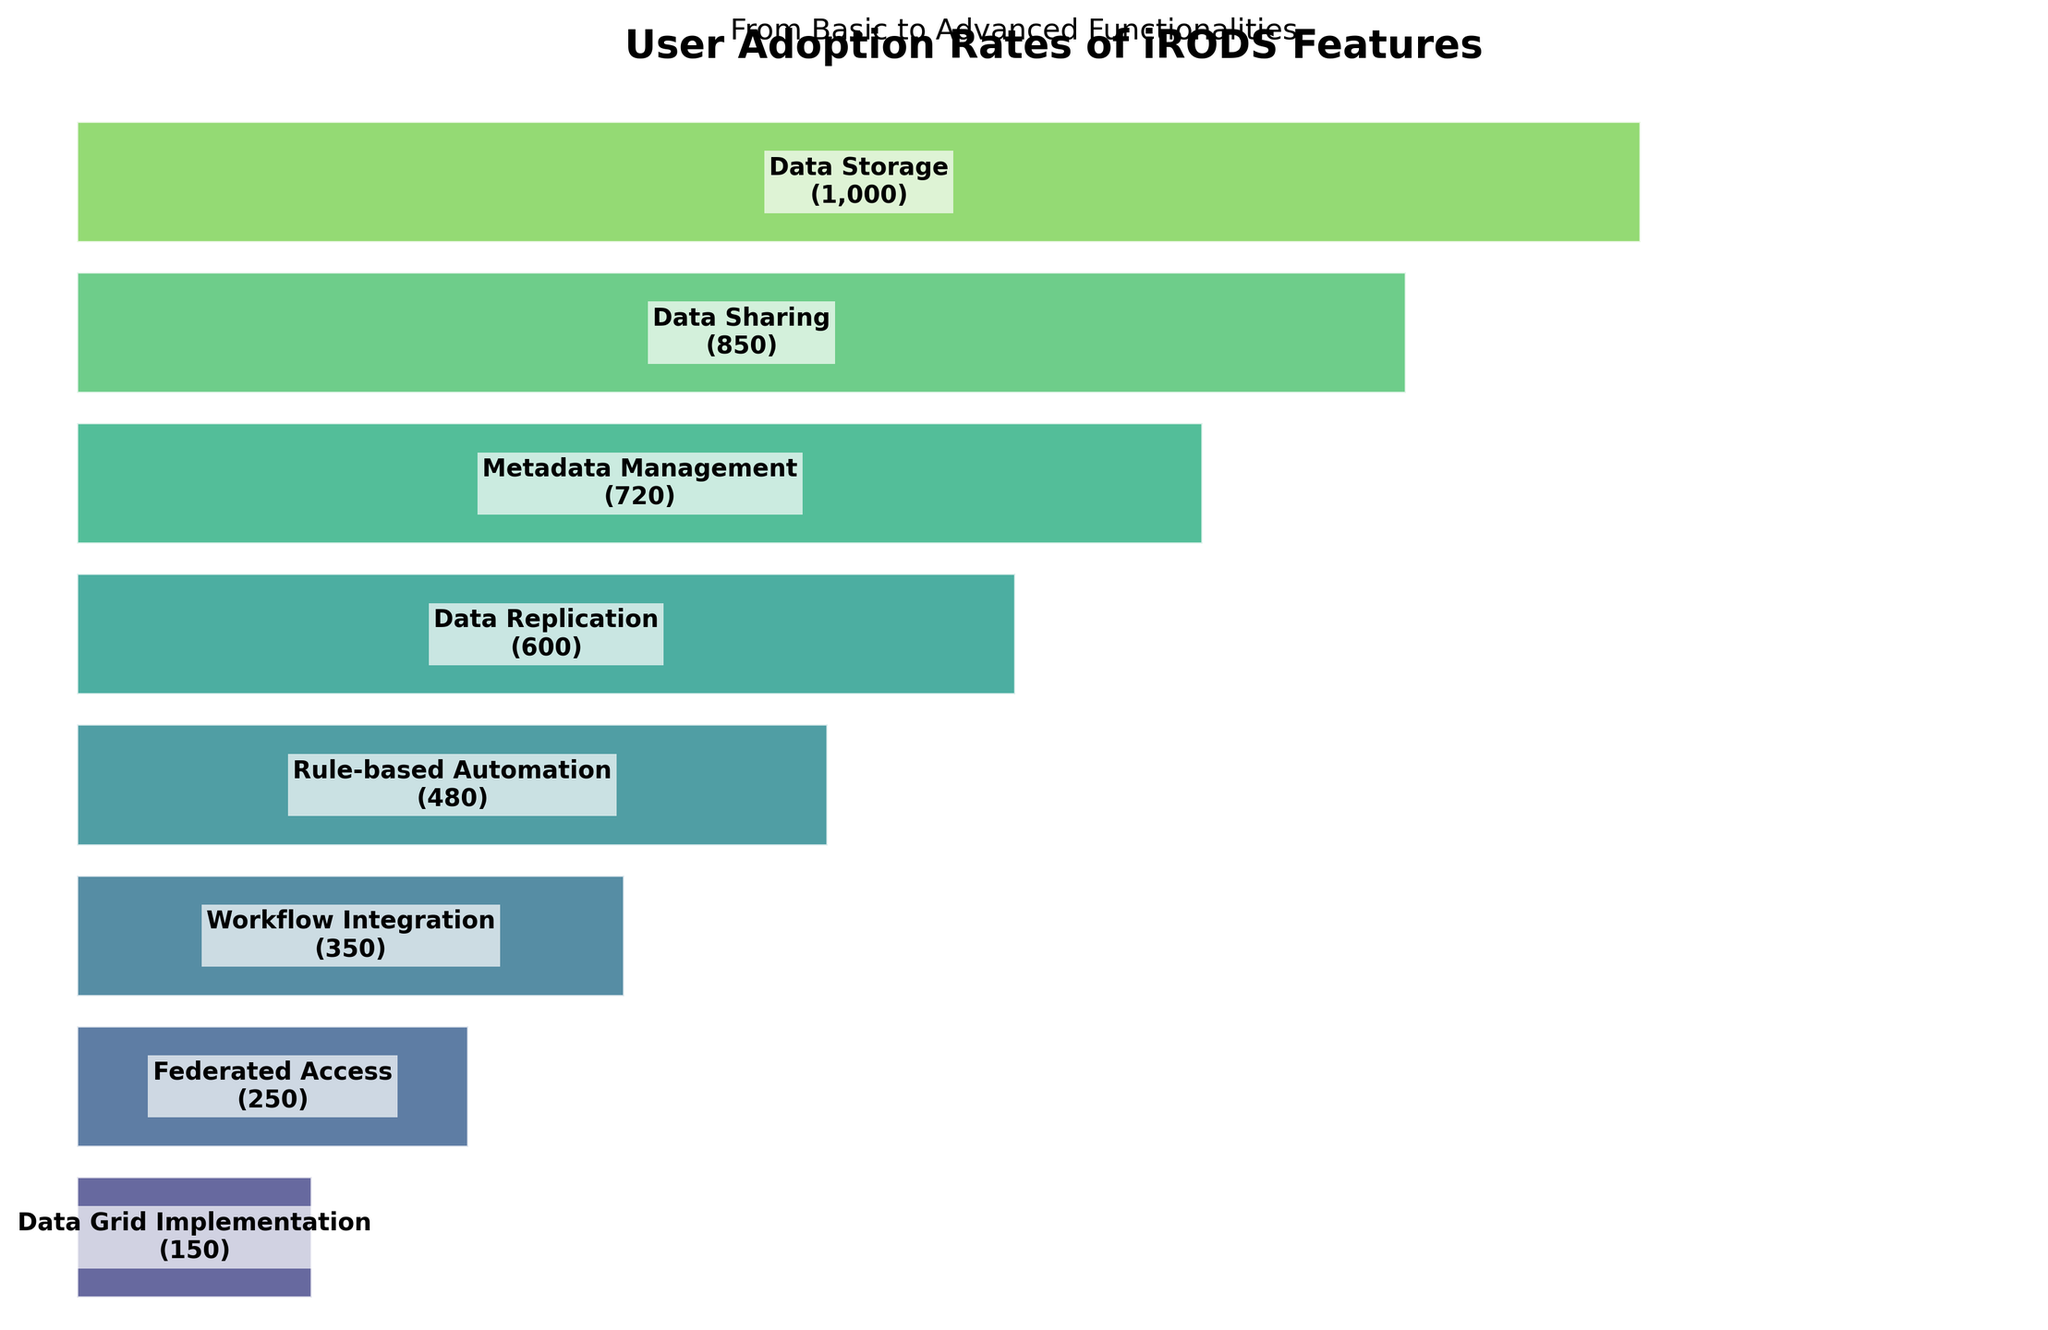What's the title of the chart? The title is located at the top of the figure and summarizes the content of the chart. The title is displayed in a bigger and bold font compared to other text in the figure.
Answer: User Adoption Rates of iRODS Features How many features are displayed in the chart? By counting the number of distinct segments or labels in the funnel chart, we can determine the number of features displayed. Each segment represents a different feature.
Answer: 8 Which iRODS feature has the highest user adoption rate? The feature with the highest user count is at the widest part of the funnel, at the top of the chart. This segment represents the most basic and widely adopted feature.
Answer: Data Storage Which feature has fewer users, Data Sharing or Metadata Management? By locating the segments for Data Sharing and Metadata Management, we compare the width of these segments or check the user count labels associated with them.
Answer: Metadata Management Calculate the total number of users using the advanced functionalities (i.e., the last four features). Sum the user counts for the last four features listed in the funnel. These features are Data Replication, Rule-based Automation, Workflow Integration, and Federated Access.
Answer: 1,180 What percentage of users adopt Rule-based Automation out of those who use Data Storage? Divide the number of users for Rule-based Automation by the number of users for Data Storage and multiply by 100 to get the percentage. (480 / 1000) * 100
Answer: 48% How does the adoption rate of Data Sharing compare to Data Storage? By looking at the width of the segments or comparing the numerical values for user counts, we can see how the adoption rates stack up. Data Sharing has fewer users than Data Storage.
Answer: Less Which feature transitions show the biggest drop in user adoption? By observing the differences in widths between consecutive segments in the funnel, we identify the largest drop in user count. Look for the sections where the funnel narrows the most between features.
Answer: Data Sharing to Metadata Management What is the trend in user adoption as the features become more advanced? By examining the sequential order of features from top to bottom in the funnel, it is clear that user adoption generally decreases as features become more advanced.
Answer: Decreasing 